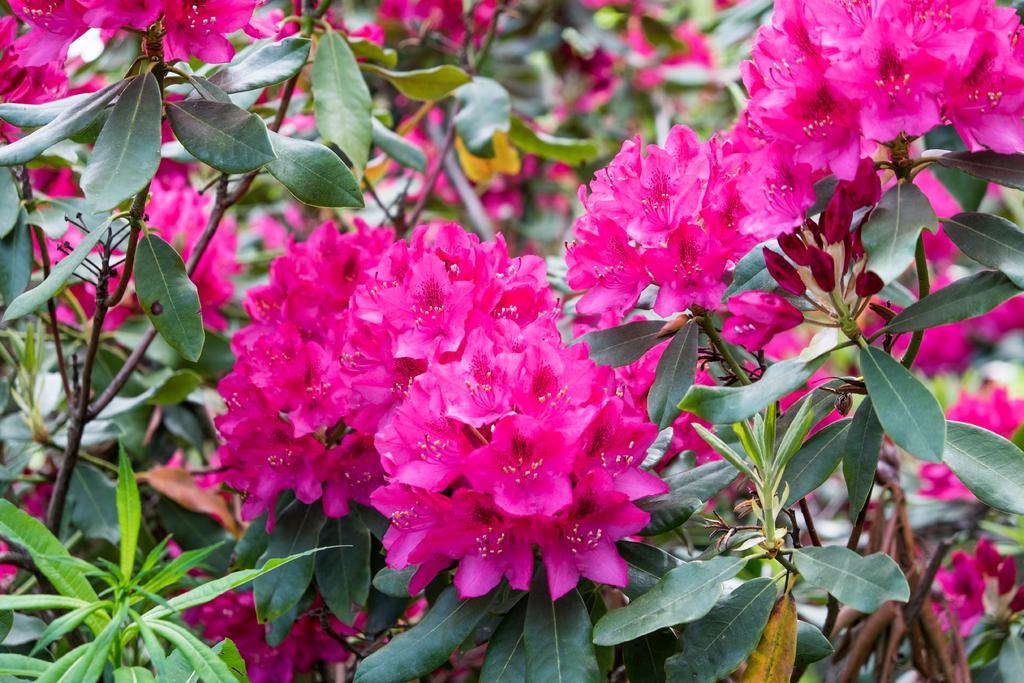Can you describe this image briefly? This image is taken outdoors. In this image there are a few plants with leaves, stems and many flowers. Those flowers are dark pink in color. 